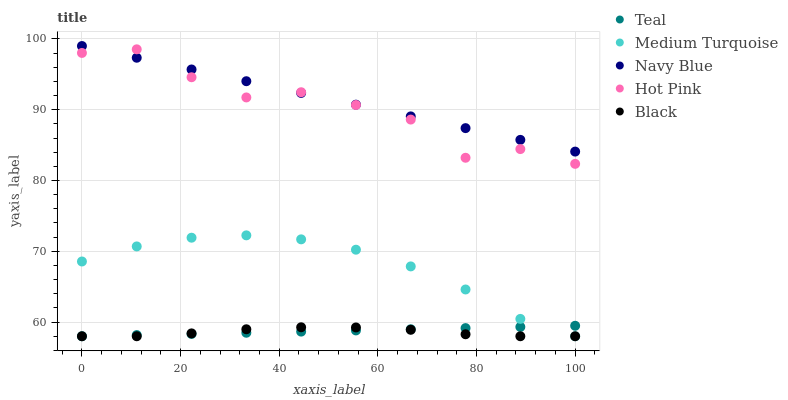Does Black have the minimum area under the curve?
Answer yes or no. Yes. Does Navy Blue have the maximum area under the curve?
Answer yes or no. Yes. Does Hot Pink have the minimum area under the curve?
Answer yes or no. No. Does Hot Pink have the maximum area under the curve?
Answer yes or no. No. Is Teal the smoothest?
Answer yes or no. Yes. Is Hot Pink the roughest?
Answer yes or no. Yes. Is Black the smoothest?
Answer yes or no. No. Is Black the roughest?
Answer yes or no. No. Does Black have the lowest value?
Answer yes or no. Yes. Does Hot Pink have the lowest value?
Answer yes or no. No. Does Navy Blue have the highest value?
Answer yes or no. Yes. Does Hot Pink have the highest value?
Answer yes or no. No. Is Teal less than Navy Blue?
Answer yes or no. Yes. Is Hot Pink greater than Black?
Answer yes or no. Yes. Does Medium Turquoise intersect Teal?
Answer yes or no. Yes. Is Medium Turquoise less than Teal?
Answer yes or no. No. Is Medium Turquoise greater than Teal?
Answer yes or no. No. Does Teal intersect Navy Blue?
Answer yes or no. No. 